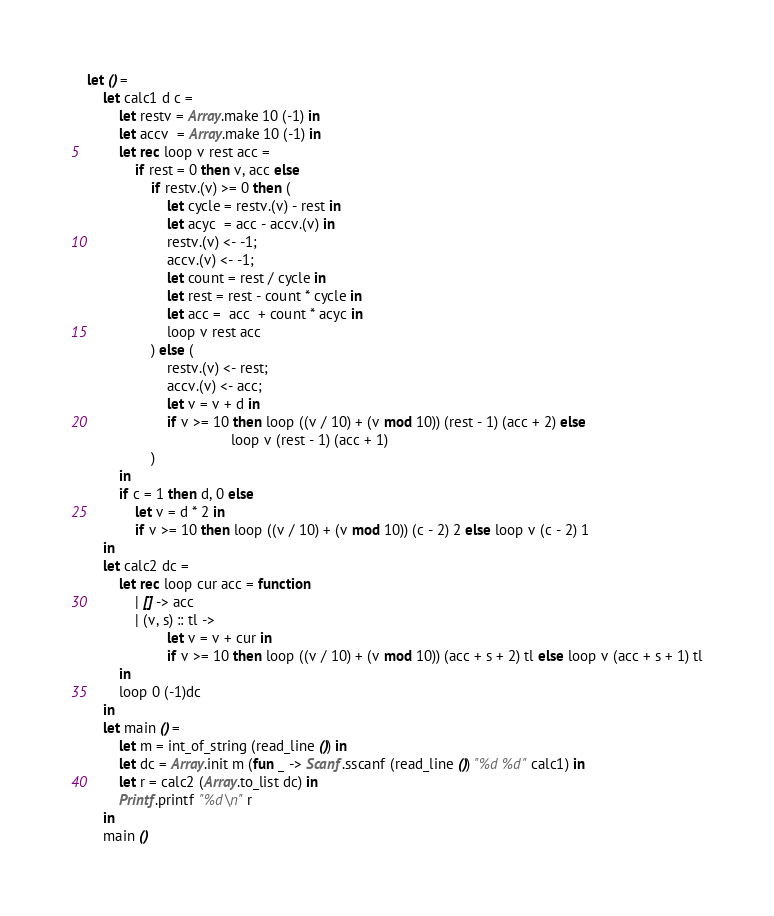<code> <loc_0><loc_0><loc_500><loc_500><_OCaml_>let () =
    let calc1 d c =
        let restv = Array.make 10 (-1) in
        let accv  = Array.make 10 (-1) in
        let rec loop v rest acc =
            if rest = 0 then v, acc else
                if restv.(v) >= 0 then (
                    let cycle = restv.(v) - rest in
                    let acyc  = acc - accv.(v) in
                    restv.(v) <- -1;
                    accv.(v) <- -1;
                    let count = rest / cycle in
                    let rest = rest - count * cycle in
                    let acc =  acc  + count * acyc in
                    loop v rest acc 
                ) else (
                    restv.(v) <- rest;
                    accv.(v) <- acc;
                    let v = v + d in
                    if v >= 10 then loop ((v / 10) + (v mod 10)) (rest - 1) (acc + 2) else
                                    loop v (rest - 1) (acc + 1)
                )
        in
        if c = 1 then d, 0 else
            let v = d * 2 in
            if v >= 10 then loop ((v / 10) + (v mod 10)) (c - 2) 2 else loop v (c - 2) 1 
    in
    let calc2 dc =
        let rec loop cur acc = function
            | [] -> acc
            | (v, s) :: tl ->
                    let v = v + cur in
                    if v >= 10 then loop ((v / 10) + (v mod 10)) (acc + s + 2) tl else loop v (acc + s + 1) tl
        in
        loop 0 (-1)dc
    in
    let main () =
        let m = int_of_string (read_line ()) in
        let dc = Array.init m (fun _ -> Scanf.sscanf (read_line ()) "%d %d" calc1) in
        let r = calc2 (Array.to_list dc) in
        Printf.printf "%d\n" r
    in
    main ()</code> 